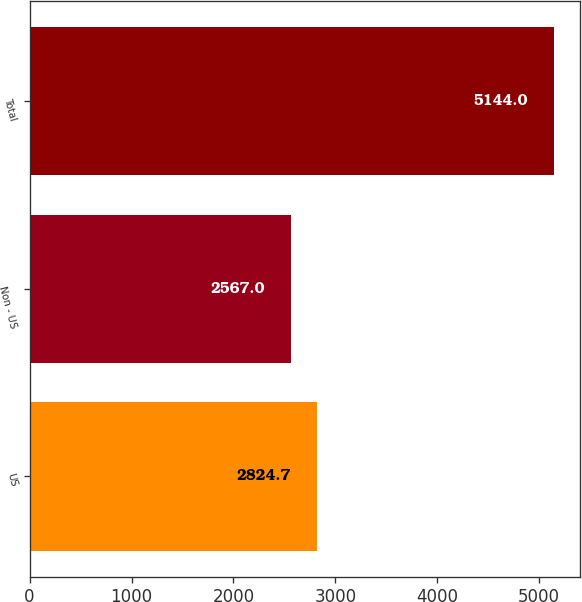Convert chart to OTSL. <chart><loc_0><loc_0><loc_500><loc_500><bar_chart><fcel>US<fcel>Non - US<fcel>Total<nl><fcel>2824.7<fcel>2567<fcel>5144<nl></chart> 